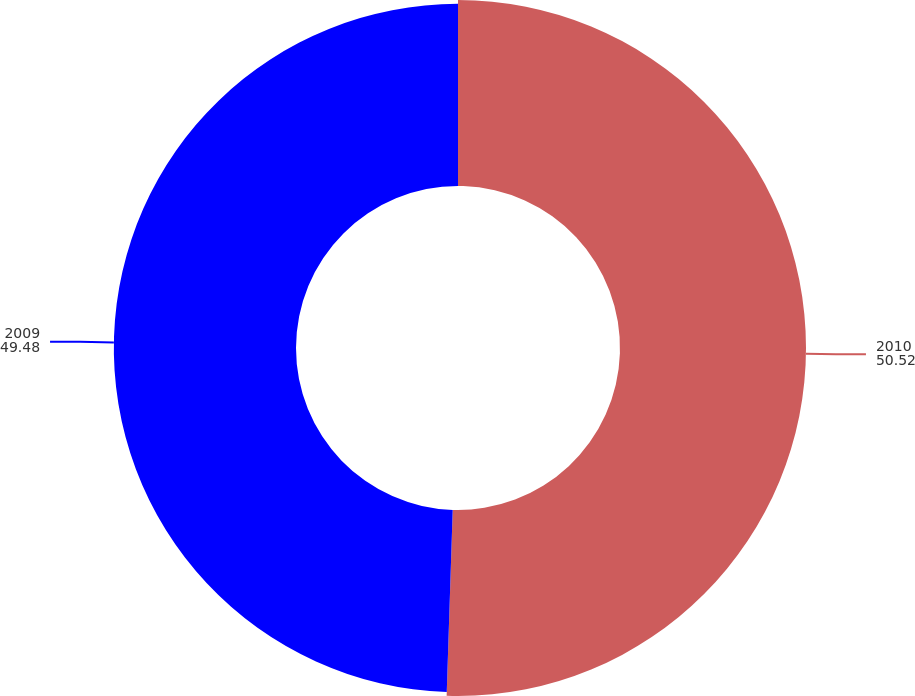Convert chart to OTSL. <chart><loc_0><loc_0><loc_500><loc_500><pie_chart><fcel>2010<fcel>2009<nl><fcel>50.52%<fcel>49.48%<nl></chart> 